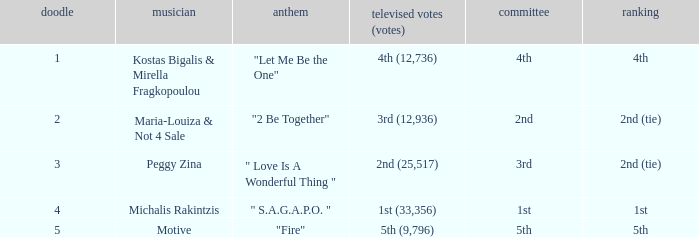The song "2 Be Together" had what jury? 2nd. 